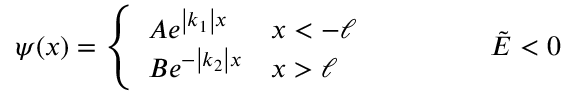<formula> <loc_0><loc_0><loc_500><loc_500>\psi ( x ) = \left \{ \begin{array} { l l } { A e ^ { \left | k _ { 1 } \right | x } } & { x < - \ell } \\ { B e ^ { - \left | k _ { 2 } \right | x } } & { x > \ell } \end{array} \quad \tilde { E } < 0</formula> 